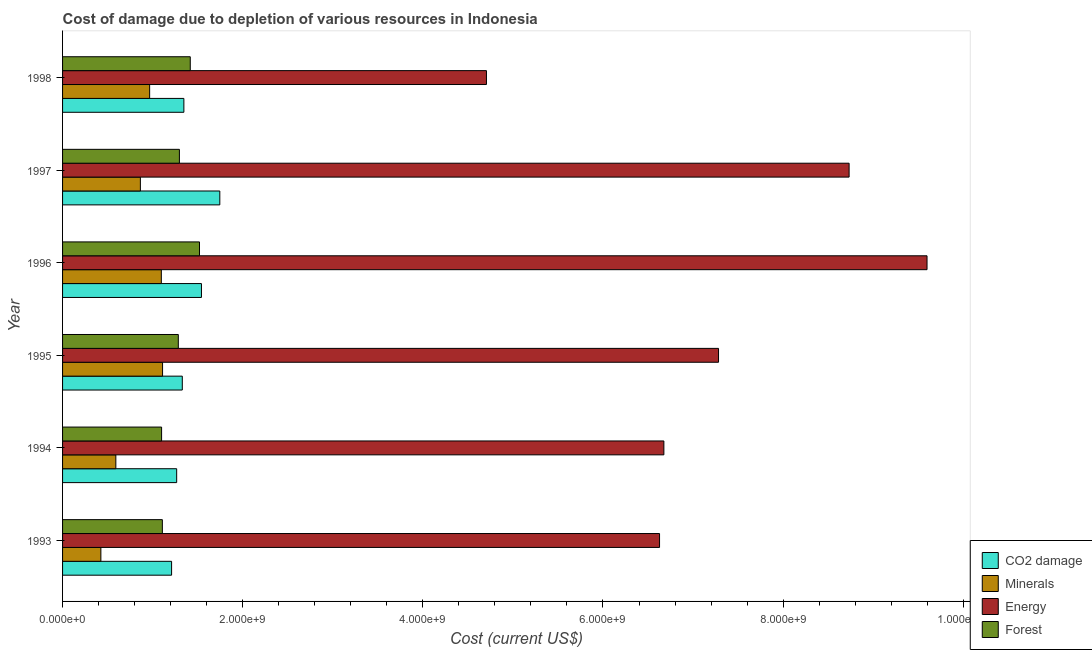Are the number of bars per tick equal to the number of legend labels?
Keep it short and to the point. Yes. How many bars are there on the 1st tick from the bottom?
Provide a short and direct response. 4. What is the cost of damage due to depletion of minerals in 1996?
Make the answer very short. 1.10e+09. Across all years, what is the maximum cost of damage due to depletion of energy?
Offer a very short reply. 9.60e+09. Across all years, what is the minimum cost of damage due to depletion of energy?
Keep it short and to the point. 4.71e+09. In which year was the cost of damage due to depletion of forests minimum?
Keep it short and to the point. 1994. What is the total cost of damage due to depletion of minerals in the graph?
Your answer should be very brief. 5.05e+09. What is the difference between the cost of damage due to depletion of energy in 1994 and that in 1997?
Provide a succinct answer. -2.06e+09. What is the difference between the cost of damage due to depletion of coal in 1997 and the cost of damage due to depletion of minerals in 1994?
Offer a very short reply. 1.15e+09. What is the average cost of damage due to depletion of minerals per year?
Ensure brevity in your answer.  8.42e+08. In the year 1994, what is the difference between the cost of damage due to depletion of coal and cost of damage due to depletion of minerals?
Make the answer very short. 6.75e+08. What is the ratio of the cost of damage due to depletion of energy in 1995 to that in 1996?
Offer a terse response. 0.76. Is the difference between the cost of damage due to depletion of minerals in 1995 and 1997 greater than the difference between the cost of damage due to depletion of forests in 1995 and 1997?
Give a very brief answer. Yes. What is the difference between the highest and the second highest cost of damage due to depletion of energy?
Offer a terse response. 8.65e+08. What is the difference between the highest and the lowest cost of damage due to depletion of forests?
Your answer should be compact. 4.21e+08. In how many years, is the cost of damage due to depletion of energy greater than the average cost of damage due to depletion of energy taken over all years?
Ensure brevity in your answer.  3. Is the sum of the cost of damage due to depletion of coal in 1994 and 1995 greater than the maximum cost of damage due to depletion of forests across all years?
Give a very brief answer. Yes. What does the 4th bar from the top in 1997 represents?
Give a very brief answer. CO2 damage. What does the 2nd bar from the bottom in 1995 represents?
Make the answer very short. Minerals. Are all the bars in the graph horizontal?
Offer a terse response. Yes. How many years are there in the graph?
Your answer should be compact. 6. Does the graph contain any zero values?
Offer a very short reply. No. Does the graph contain grids?
Provide a succinct answer. No. How many legend labels are there?
Give a very brief answer. 4. How are the legend labels stacked?
Your answer should be compact. Vertical. What is the title of the graph?
Provide a short and direct response. Cost of damage due to depletion of various resources in Indonesia . Does "Taxes on exports" appear as one of the legend labels in the graph?
Keep it short and to the point. No. What is the label or title of the X-axis?
Give a very brief answer. Cost (current US$). What is the label or title of the Y-axis?
Ensure brevity in your answer.  Year. What is the Cost (current US$) of CO2 damage in 1993?
Your answer should be compact. 1.21e+09. What is the Cost (current US$) in Minerals in 1993?
Ensure brevity in your answer.  4.25e+08. What is the Cost (current US$) in Energy in 1993?
Ensure brevity in your answer.  6.63e+09. What is the Cost (current US$) of Forest in 1993?
Make the answer very short. 1.11e+09. What is the Cost (current US$) in CO2 damage in 1994?
Keep it short and to the point. 1.27e+09. What is the Cost (current US$) in Minerals in 1994?
Keep it short and to the point. 5.92e+08. What is the Cost (current US$) of Energy in 1994?
Keep it short and to the point. 6.68e+09. What is the Cost (current US$) of Forest in 1994?
Give a very brief answer. 1.10e+09. What is the Cost (current US$) of CO2 damage in 1995?
Offer a terse response. 1.33e+09. What is the Cost (current US$) in Minerals in 1995?
Your response must be concise. 1.11e+09. What is the Cost (current US$) in Energy in 1995?
Provide a succinct answer. 7.28e+09. What is the Cost (current US$) in Forest in 1995?
Keep it short and to the point. 1.29e+09. What is the Cost (current US$) of CO2 damage in 1996?
Ensure brevity in your answer.  1.54e+09. What is the Cost (current US$) in Minerals in 1996?
Provide a short and direct response. 1.10e+09. What is the Cost (current US$) of Energy in 1996?
Make the answer very short. 9.60e+09. What is the Cost (current US$) in Forest in 1996?
Provide a succinct answer. 1.52e+09. What is the Cost (current US$) of CO2 damage in 1997?
Your response must be concise. 1.75e+09. What is the Cost (current US$) in Minerals in 1997?
Make the answer very short. 8.64e+08. What is the Cost (current US$) of Energy in 1997?
Ensure brevity in your answer.  8.73e+09. What is the Cost (current US$) in Forest in 1997?
Your response must be concise. 1.30e+09. What is the Cost (current US$) of CO2 damage in 1998?
Offer a very short reply. 1.35e+09. What is the Cost (current US$) of Minerals in 1998?
Provide a short and direct response. 9.67e+08. What is the Cost (current US$) of Energy in 1998?
Offer a terse response. 4.71e+09. What is the Cost (current US$) of Forest in 1998?
Offer a terse response. 1.42e+09. Across all years, what is the maximum Cost (current US$) of CO2 damage?
Provide a short and direct response. 1.75e+09. Across all years, what is the maximum Cost (current US$) of Minerals?
Your answer should be very brief. 1.11e+09. Across all years, what is the maximum Cost (current US$) in Energy?
Your response must be concise. 9.60e+09. Across all years, what is the maximum Cost (current US$) of Forest?
Your answer should be compact. 1.52e+09. Across all years, what is the minimum Cost (current US$) in CO2 damage?
Make the answer very short. 1.21e+09. Across all years, what is the minimum Cost (current US$) of Minerals?
Your answer should be very brief. 4.25e+08. Across all years, what is the minimum Cost (current US$) in Energy?
Provide a succinct answer. 4.71e+09. Across all years, what is the minimum Cost (current US$) of Forest?
Your response must be concise. 1.10e+09. What is the total Cost (current US$) of CO2 damage in the graph?
Make the answer very short. 8.44e+09. What is the total Cost (current US$) of Minerals in the graph?
Your answer should be very brief. 5.05e+09. What is the total Cost (current US$) in Energy in the graph?
Provide a short and direct response. 4.36e+1. What is the total Cost (current US$) of Forest in the graph?
Your response must be concise. 7.73e+09. What is the difference between the Cost (current US$) in CO2 damage in 1993 and that in 1994?
Your response must be concise. -5.64e+07. What is the difference between the Cost (current US$) in Minerals in 1993 and that in 1994?
Offer a terse response. -1.66e+08. What is the difference between the Cost (current US$) in Energy in 1993 and that in 1994?
Ensure brevity in your answer.  -4.81e+07. What is the difference between the Cost (current US$) in Forest in 1993 and that in 1994?
Your answer should be very brief. 8.36e+06. What is the difference between the Cost (current US$) of CO2 damage in 1993 and that in 1995?
Your answer should be compact. -1.19e+08. What is the difference between the Cost (current US$) in Minerals in 1993 and that in 1995?
Your answer should be compact. -6.85e+08. What is the difference between the Cost (current US$) in Energy in 1993 and that in 1995?
Give a very brief answer. -6.55e+08. What is the difference between the Cost (current US$) in Forest in 1993 and that in 1995?
Make the answer very short. -1.77e+08. What is the difference between the Cost (current US$) in CO2 damage in 1993 and that in 1996?
Provide a short and direct response. -3.32e+08. What is the difference between the Cost (current US$) in Minerals in 1993 and that in 1996?
Your answer should be compact. -6.71e+08. What is the difference between the Cost (current US$) of Energy in 1993 and that in 1996?
Provide a succinct answer. -2.97e+09. What is the difference between the Cost (current US$) of Forest in 1993 and that in 1996?
Make the answer very short. -4.12e+08. What is the difference between the Cost (current US$) in CO2 damage in 1993 and that in 1997?
Offer a terse response. -5.35e+08. What is the difference between the Cost (current US$) in Minerals in 1993 and that in 1997?
Provide a short and direct response. -4.39e+08. What is the difference between the Cost (current US$) of Energy in 1993 and that in 1997?
Your response must be concise. -2.10e+09. What is the difference between the Cost (current US$) in Forest in 1993 and that in 1997?
Ensure brevity in your answer.  -1.89e+08. What is the difference between the Cost (current US$) in CO2 damage in 1993 and that in 1998?
Offer a terse response. -1.36e+08. What is the difference between the Cost (current US$) in Minerals in 1993 and that in 1998?
Keep it short and to the point. -5.41e+08. What is the difference between the Cost (current US$) in Energy in 1993 and that in 1998?
Provide a short and direct response. 1.92e+09. What is the difference between the Cost (current US$) of Forest in 1993 and that in 1998?
Your answer should be very brief. -3.10e+08. What is the difference between the Cost (current US$) of CO2 damage in 1994 and that in 1995?
Ensure brevity in your answer.  -6.25e+07. What is the difference between the Cost (current US$) in Minerals in 1994 and that in 1995?
Ensure brevity in your answer.  -5.19e+08. What is the difference between the Cost (current US$) in Energy in 1994 and that in 1995?
Provide a short and direct response. -6.07e+08. What is the difference between the Cost (current US$) of Forest in 1994 and that in 1995?
Your answer should be very brief. -1.86e+08. What is the difference between the Cost (current US$) in CO2 damage in 1994 and that in 1996?
Make the answer very short. -2.75e+08. What is the difference between the Cost (current US$) in Minerals in 1994 and that in 1996?
Provide a short and direct response. -5.05e+08. What is the difference between the Cost (current US$) in Energy in 1994 and that in 1996?
Ensure brevity in your answer.  -2.92e+09. What is the difference between the Cost (current US$) of Forest in 1994 and that in 1996?
Your answer should be very brief. -4.21e+08. What is the difference between the Cost (current US$) in CO2 damage in 1994 and that in 1997?
Offer a very short reply. -4.79e+08. What is the difference between the Cost (current US$) of Minerals in 1994 and that in 1997?
Your response must be concise. -2.72e+08. What is the difference between the Cost (current US$) of Energy in 1994 and that in 1997?
Offer a terse response. -2.06e+09. What is the difference between the Cost (current US$) of Forest in 1994 and that in 1997?
Offer a very short reply. -1.98e+08. What is the difference between the Cost (current US$) in CO2 damage in 1994 and that in 1998?
Give a very brief answer. -8.01e+07. What is the difference between the Cost (current US$) of Minerals in 1994 and that in 1998?
Provide a succinct answer. -3.75e+08. What is the difference between the Cost (current US$) in Energy in 1994 and that in 1998?
Provide a succinct answer. 1.97e+09. What is the difference between the Cost (current US$) in Forest in 1994 and that in 1998?
Your response must be concise. -3.18e+08. What is the difference between the Cost (current US$) in CO2 damage in 1995 and that in 1996?
Your answer should be compact. -2.13e+08. What is the difference between the Cost (current US$) in Minerals in 1995 and that in 1996?
Offer a very short reply. 1.37e+07. What is the difference between the Cost (current US$) in Energy in 1995 and that in 1996?
Give a very brief answer. -2.31e+09. What is the difference between the Cost (current US$) in Forest in 1995 and that in 1996?
Provide a short and direct response. -2.35e+08. What is the difference between the Cost (current US$) of CO2 damage in 1995 and that in 1997?
Offer a terse response. -4.17e+08. What is the difference between the Cost (current US$) in Minerals in 1995 and that in 1997?
Provide a short and direct response. 2.46e+08. What is the difference between the Cost (current US$) in Energy in 1995 and that in 1997?
Ensure brevity in your answer.  -1.45e+09. What is the difference between the Cost (current US$) in Forest in 1995 and that in 1997?
Your response must be concise. -1.22e+07. What is the difference between the Cost (current US$) of CO2 damage in 1995 and that in 1998?
Your answer should be compact. -1.76e+07. What is the difference between the Cost (current US$) of Minerals in 1995 and that in 1998?
Keep it short and to the point. 1.44e+08. What is the difference between the Cost (current US$) in Energy in 1995 and that in 1998?
Ensure brevity in your answer.  2.58e+09. What is the difference between the Cost (current US$) in Forest in 1995 and that in 1998?
Provide a short and direct response. -1.33e+08. What is the difference between the Cost (current US$) of CO2 damage in 1996 and that in 1997?
Offer a very short reply. -2.04e+08. What is the difference between the Cost (current US$) in Minerals in 1996 and that in 1997?
Provide a short and direct response. 2.33e+08. What is the difference between the Cost (current US$) of Energy in 1996 and that in 1997?
Your response must be concise. 8.65e+08. What is the difference between the Cost (current US$) of Forest in 1996 and that in 1997?
Your answer should be very brief. 2.23e+08. What is the difference between the Cost (current US$) in CO2 damage in 1996 and that in 1998?
Provide a short and direct response. 1.95e+08. What is the difference between the Cost (current US$) of Minerals in 1996 and that in 1998?
Offer a very short reply. 1.30e+08. What is the difference between the Cost (current US$) of Energy in 1996 and that in 1998?
Provide a short and direct response. 4.89e+09. What is the difference between the Cost (current US$) in Forest in 1996 and that in 1998?
Provide a succinct answer. 1.02e+08. What is the difference between the Cost (current US$) of CO2 damage in 1997 and that in 1998?
Provide a short and direct response. 3.99e+08. What is the difference between the Cost (current US$) in Minerals in 1997 and that in 1998?
Provide a succinct answer. -1.03e+08. What is the difference between the Cost (current US$) of Energy in 1997 and that in 1998?
Your answer should be very brief. 4.03e+09. What is the difference between the Cost (current US$) in Forest in 1997 and that in 1998?
Make the answer very short. -1.21e+08. What is the difference between the Cost (current US$) of CO2 damage in 1993 and the Cost (current US$) of Minerals in 1994?
Your answer should be compact. 6.19e+08. What is the difference between the Cost (current US$) of CO2 damage in 1993 and the Cost (current US$) of Energy in 1994?
Provide a succinct answer. -5.47e+09. What is the difference between the Cost (current US$) of CO2 damage in 1993 and the Cost (current US$) of Forest in 1994?
Keep it short and to the point. 1.11e+08. What is the difference between the Cost (current US$) in Minerals in 1993 and the Cost (current US$) in Energy in 1994?
Provide a short and direct response. -6.25e+09. What is the difference between the Cost (current US$) in Minerals in 1993 and the Cost (current US$) in Forest in 1994?
Provide a succinct answer. -6.74e+08. What is the difference between the Cost (current US$) of Energy in 1993 and the Cost (current US$) of Forest in 1994?
Your response must be concise. 5.53e+09. What is the difference between the Cost (current US$) of CO2 damage in 1993 and the Cost (current US$) of Minerals in 1995?
Give a very brief answer. 1.00e+08. What is the difference between the Cost (current US$) of CO2 damage in 1993 and the Cost (current US$) of Energy in 1995?
Give a very brief answer. -6.07e+09. What is the difference between the Cost (current US$) of CO2 damage in 1993 and the Cost (current US$) of Forest in 1995?
Keep it short and to the point. -7.47e+07. What is the difference between the Cost (current US$) in Minerals in 1993 and the Cost (current US$) in Energy in 1995?
Offer a very short reply. -6.86e+09. What is the difference between the Cost (current US$) of Minerals in 1993 and the Cost (current US$) of Forest in 1995?
Make the answer very short. -8.60e+08. What is the difference between the Cost (current US$) in Energy in 1993 and the Cost (current US$) in Forest in 1995?
Provide a succinct answer. 5.34e+09. What is the difference between the Cost (current US$) of CO2 damage in 1993 and the Cost (current US$) of Minerals in 1996?
Make the answer very short. 1.14e+08. What is the difference between the Cost (current US$) in CO2 damage in 1993 and the Cost (current US$) in Energy in 1996?
Provide a succinct answer. -8.39e+09. What is the difference between the Cost (current US$) of CO2 damage in 1993 and the Cost (current US$) of Forest in 1996?
Provide a succinct answer. -3.10e+08. What is the difference between the Cost (current US$) in Minerals in 1993 and the Cost (current US$) in Energy in 1996?
Offer a terse response. -9.17e+09. What is the difference between the Cost (current US$) in Minerals in 1993 and the Cost (current US$) in Forest in 1996?
Ensure brevity in your answer.  -1.10e+09. What is the difference between the Cost (current US$) of Energy in 1993 and the Cost (current US$) of Forest in 1996?
Offer a terse response. 5.11e+09. What is the difference between the Cost (current US$) of CO2 damage in 1993 and the Cost (current US$) of Minerals in 1997?
Your response must be concise. 3.47e+08. What is the difference between the Cost (current US$) of CO2 damage in 1993 and the Cost (current US$) of Energy in 1997?
Keep it short and to the point. -7.52e+09. What is the difference between the Cost (current US$) in CO2 damage in 1993 and the Cost (current US$) in Forest in 1997?
Your response must be concise. -8.68e+07. What is the difference between the Cost (current US$) in Minerals in 1993 and the Cost (current US$) in Energy in 1997?
Your answer should be compact. -8.31e+09. What is the difference between the Cost (current US$) of Minerals in 1993 and the Cost (current US$) of Forest in 1997?
Offer a very short reply. -8.72e+08. What is the difference between the Cost (current US$) in Energy in 1993 and the Cost (current US$) in Forest in 1997?
Offer a terse response. 5.33e+09. What is the difference between the Cost (current US$) of CO2 damage in 1993 and the Cost (current US$) of Minerals in 1998?
Your answer should be compact. 2.44e+08. What is the difference between the Cost (current US$) in CO2 damage in 1993 and the Cost (current US$) in Energy in 1998?
Offer a terse response. -3.50e+09. What is the difference between the Cost (current US$) in CO2 damage in 1993 and the Cost (current US$) in Forest in 1998?
Offer a very short reply. -2.07e+08. What is the difference between the Cost (current US$) of Minerals in 1993 and the Cost (current US$) of Energy in 1998?
Keep it short and to the point. -4.28e+09. What is the difference between the Cost (current US$) in Minerals in 1993 and the Cost (current US$) in Forest in 1998?
Keep it short and to the point. -9.93e+08. What is the difference between the Cost (current US$) in Energy in 1993 and the Cost (current US$) in Forest in 1998?
Provide a short and direct response. 5.21e+09. What is the difference between the Cost (current US$) of CO2 damage in 1994 and the Cost (current US$) of Minerals in 1995?
Give a very brief answer. 1.57e+08. What is the difference between the Cost (current US$) of CO2 damage in 1994 and the Cost (current US$) of Energy in 1995?
Your response must be concise. -6.02e+09. What is the difference between the Cost (current US$) of CO2 damage in 1994 and the Cost (current US$) of Forest in 1995?
Your answer should be compact. -1.83e+07. What is the difference between the Cost (current US$) in Minerals in 1994 and the Cost (current US$) in Energy in 1995?
Make the answer very short. -6.69e+09. What is the difference between the Cost (current US$) in Minerals in 1994 and the Cost (current US$) in Forest in 1995?
Keep it short and to the point. -6.94e+08. What is the difference between the Cost (current US$) of Energy in 1994 and the Cost (current US$) of Forest in 1995?
Your answer should be very brief. 5.39e+09. What is the difference between the Cost (current US$) in CO2 damage in 1994 and the Cost (current US$) in Minerals in 1996?
Give a very brief answer. 1.70e+08. What is the difference between the Cost (current US$) in CO2 damage in 1994 and the Cost (current US$) in Energy in 1996?
Ensure brevity in your answer.  -8.33e+09. What is the difference between the Cost (current US$) in CO2 damage in 1994 and the Cost (current US$) in Forest in 1996?
Offer a terse response. -2.54e+08. What is the difference between the Cost (current US$) of Minerals in 1994 and the Cost (current US$) of Energy in 1996?
Your response must be concise. -9.01e+09. What is the difference between the Cost (current US$) of Minerals in 1994 and the Cost (current US$) of Forest in 1996?
Your answer should be very brief. -9.29e+08. What is the difference between the Cost (current US$) of Energy in 1994 and the Cost (current US$) of Forest in 1996?
Offer a terse response. 5.16e+09. What is the difference between the Cost (current US$) in CO2 damage in 1994 and the Cost (current US$) in Minerals in 1997?
Your response must be concise. 4.03e+08. What is the difference between the Cost (current US$) of CO2 damage in 1994 and the Cost (current US$) of Energy in 1997?
Ensure brevity in your answer.  -7.47e+09. What is the difference between the Cost (current US$) of CO2 damage in 1994 and the Cost (current US$) of Forest in 1997?
Offer a terse response. -3.05e+07. What is the difference between the Cost (current US$) of Minerals in 1994 and the Cost (current US$) of Energy in 1997?
Give a very brief answer. -8.14e+09. What is the difference between the Cost (current US$) in Minerals in 1994 and the Cost (current US$) in Forest in 1997?
Give a very brief answer. -7.06e+08. What is the difference between the Cost (current US$) of Energy in 1994 and the Cost (current US$) of Forest in 1997?
Offer a terse response. 5.38e+09. What is the difference between the Cost (current US$) of CO2 damage in 1994 and the Cost (current US$) of Minerals in 1998?
Ensure brevity in your answer.  3.00e+08. What is the difference between the Cost (current US$) in CO2 damage in 1994 and the Cost (current US$) in Energy in 1998?
Ensure brevity in your answer.  -3.44e+09. What is the difference between the Cost (current US$) in CO2 damage in 1994 and the Cost (current US$) in Forest in 1998?
Provide a succinct answer. -1.51e+08. What is the difference between the Cost (current US$) in Minerals in 1994 and the Cost (current US$) in Energy in 1998?
Keep it short and to the point. -4.11e+09. What is the difference between the Cost (current US$) of Minerals in 1994 and the Cost (current US$) of Forest in 1998?
Your response must be concise. -8.26e+08. What is the difference between the Cost (current US$) in Energy in 1994 and the Cost (current US$) in Forest in 1998?
Offer a very short reply. 5.26e+09. What is the difference between the Cost (current US$) of CO2 damage in 1995 and the Cost (current US$) of Minerals in 1996?
Provide a short and direct response. 2.33e+08. What is the difference between the Cost (current US$) of CO2 damage in 1995 and the Cost (current US$) of Energy in 1996?
Offer a terse response. -8.27e+09. What is the difference between the Cost (current US$) of CO2 damage in 1995 and the Cost (current US$) of Forest in 1996?
Make the answer very short. -1.91e+08. What is the difference between the Cost (current US$) of Minerals in 1995 and the Cost (current US$) of Energy in 1996?
Keep it short and to the point. -8.49e+09. What is the difference between the Cost (current US$) of Minerals in 1995 and the Cost (current US$) of Forest in 1996?
Provide a succinct answer. -4.10e+08. What is the difference between the Cost (current US$) in Energy in 1995 and the Cost (current US$) in Forest in 1996?
Provide a short and direct response. 5.76e+09. What is the difference between the Cost (current US$) of CO2 damage in 1995 and the Cost (current US$) of Minerals in 1997?
Make the answer very short. 4.65e+08. What is the difference between the Cost (current US$) in CO2 damage in 1995 and the Cost (current US$) in Energy in 1997?
Give a very brief answer. -7.40e+09. What is the difference between the Cost (current US$) of CO2 damage in 1995 and the Cost (current US$) of Forest in 1997?
Give a very brief answer. 3.20e+07. What is the difference between the Cost (current US$) of Minerals in 1995 and the Cost (current US$) of Energy in 1997?
Give a very brief answer. -7.62e+09. What is the difference between the Cost (current US$) in Minerals in 1995 and the Cost (current US$) in Forest in 1997?
Give a very brief answer. -1.87e+08. What is the difference between the Cost (current US$) in Energy in 1995 and the Cost (current US$) in Forest in 1997?
Keep it short and to the point. 5.99e+09. What is the difference between the Cost (current US$) of CO2 damage in 1995 and the Cost (current US$) of Minerals in 1998?
Your answer should be compact. 3.63e+08. What is the difference between the Cost (current US$) in CO2 damage in 1995 and the Cost (current US$) in Energy in 1998?
Keep it short and to the point. -3.38e+09. What is the difference between the Cost (current US$) in CO2 damage in 1995 and the Cost (current US$) in Forest in 1998?
Your answer should be compact. -8.86e+07. What is the difference between the Cost (current US$) in Minerals in 1995 and the Cost (current US$) in Energy in 1998?
Offer a very short reply. -3.60e+09. What is the difference between the Cost (current US$) of Minerals in 1995 and the Cost (current US$) of Forest in 1998?
Ensure brevity in your answer.  -3.08e+08. What is the difference between the Cost (current US$) in Energy in 1995 and the Cost (current US$) in Forest in 1998?
Make the answer very short. 5.87e+09. What is the difference between the Cost (current US$) in CO2 damage in 1996 and the Cost (current US$) in Minerals in 1997?
Give a very brief answer. 6.78e+08. What is the difference between the Cost (current US$) in CO2 damage in 1996 and the Cost (current US$) in Energy in 1997?
Offer a very short reply. -7.19e+09. What is the difference between the Cost (current US$) in CO2 damage in 1996 and the Cost (current US$) in Forest in 1997?
Provide a succinct answer. 2.45e+08. What is the difference between the Cost (current US$) in Minerals in 1996 and the Cost (current US$) in Energy in 1997?
Provide a short and direct response. -7.64e+09. What is the difference between the Cost (current US$) of Minerals in 1996 and the Cost (current US$) of Forest in 1997?
Provide a short and direct response. -2.01e+08. What is the difference between the Cost (current US$) in Energy in 1996 and the Cost (current US$) in Forest in 1997?
Keep it short and to the point. 8.30e+09. What is the difference between the Cost (current US$) of CO2 damage in 1996 and the Cost (current US$) of Minerals in 1998?
Provide a succinct answer. 5.75e+08. What is the difference between the Cost (current US$) of CO2 damage in 1996 and the Cost (current US$) of Energy in 1998?
Give a very brief answer. -3.16e+09. What is the difference between the Cost (current US$) in CO2 damage in 1996 and the Cost (current US$) in Forest in 1998?
Your response must be concise. 1.24e+08. What is the difference between the Cost (current US$) in Minerals in 1996 and the Cost (current US$) in Energy in 1998?
Make the answer very short. -3.61e+09. What is the difference between the Cost (current US$) of Minerals in 1996 and the Cost (current US$) of Forest in 1998?
Your response must be concise. -3.21e+08. What is the difference between the Cost (current US$) in Energy in 1996 and the Cost (current US$) in Forest in 1998?
Give a very brief answer. 8.18e+09. What is the difference between the Cost (current US$) of CO2 damage in 1997 and the Cost (current US$) of Minerals in 1998?
Give a very brief answer. 7.79e+08. What is the difference between the Cost (current US$) in CO2 damage in 1997 and the Cost (current US$) in Energy in 1998?
Your response must be concise. -2.96e+09. What is the difference between the Cost (current US$) in CO2 damage in 1997 and the Cost (current US$) in Forest in 1998?
Offer a terse response. 3.28e+08. What is the difference between the Cost (current US$) in Minerals in 1997 and the Cost (current US$) in Energy in 1998?
Provide a succinct answer. -3.84e+09. What is the difference between the Cost (current US$) in Minerals in 1997 and the Cost (current US$) in Forest in 1998?
Provide a succinct answer. -5.54e+08. What is the difference between the Cost (current US$) in Energy in 1997 and the Cost (current US$) in Forest in 1998?
Your answer should be very brief. 7.31e+09. What is the average Cost (current US$) in CO2 damage per year?
Your response must be concise. 1.41e+09. What is the average Cost (current US$) of Minerals per year?
Offer a very short reply. 8.42e+08. What is the average Cost (current US$) in Energy per year?
Give a very brief answer. 7.27e+09. What is the average Cost (current US$) of Forest per year?
Offer a very short reply. 1.29e+09. In the year 1993, what is the difference between the Cost (current US$) of CO2 damage and Cost (current US$) of Minerals?
Make the answer very short. 7.85e+08. In the year 1993, what is the difference between the Cost (current US$) of CO2 damage and Cost (current US$) of Energy?
Keep it short and to the point. -5.42e+09. In the year 1993, what is the difference between the Cost (current US$) of CO2 damage and Cost (current US$) of Forest?
Provide a short and direct response. 1.03e+08. In the year 1993, what is the difference between the Cost (current US$) of Minerals and Cost (current US$) of Energy?
Your answer should be compact. -6.20e+09. In the year 1993, what is the difference between the Cost (current US$) in Minerals and Cost (current US$) in Forest?
Make the answer very short. -6.83e+08. In the year 1993, what is the difference between the Cost (current US$) of Energy and Cost (current US$) of Forest?
Make the answer very short. 5.52e+09. In the year 1994, what is the difference between the Cost (current US$) of CO2 damage and Cost (current US$) of Minerals?
Make the answer very short. 6.75e+08. In the year 1994, what is the difference between the Cost (current US$) in CO2 damage and Cost (current US$) in Energy?
Keep it short and to the point. -5.41e+09. In the year 1994, what is the difference between the Cost (current US$) of CO2 damage and Cost (current US$) of Forest?
Offer a terse response. 1.67e+08. In the year 1994, what is the difference between the Cost (current US$) of Minerals and Cost (current US$) of Energy?
Keep it short and to the point. -6.08e+09. In the year 1994, what is the difference between the Cost (current US$) in Minerals and Cost (current US$) in Forest?
Keep it short and to the point. -5.08e+08. In the year 1994, what is the difference between the Cost (current US$) in Energy and Cost (current US$) in Forest?
Provide a succinct answer. 5.58e+09. In the year 1995, what is the difference between the Cost (current US$) of CO2 damage and Cost (current US$) of Minerals?
Your answer should be very brief. 2.19e+08. In the year 1995, what is the difference between the Cost (current US$) of CO2 damage and Cost (current US$) of Energy?
Your answer should be compact. -5.95e+09. In the year 1995, what is the difference between the Cost (current US$) in CO2 damage and Cost (current US$) in Forest?
Your answer should be very brief. 4.42e+07. In the year 1995, what is the difference between the Cost (current US$) in Minerals and Cost (current US$) in Energy?
Keep it short and to the point. -6.17e+09. In the year 1995, what is the difference between the Cost (current US$) in Minerals and Cost (current US$) in Forest?
Your answer should be compact. -1.75e+08. In the year 1995, what is the difference between the Cost (current US$) of Energy and Cost (current US$) of Forest?
Offer a very short reply. 6.00e+09. In the year 1996, what is the difference between the Cost (current US$) in CO2 damage and Cost (current US$) in Minerals?
Make the answer very short. 4.45e+08. In the year 1996, what is the difference between the Cost (current US$) of CO2 damage and Cost (current US$) of Energy?
Ensure brevity in your answer.  -8.06e+09. In the year 1996, what is the difference between the Cost (current US$) of CO2 damage and Cost (current US$) of Forest?
Your response must be concise. 2.17e+07. In the year 1996, what is the difference between the Cost (current US$) of Minerals and Cost (current US$) of Energy?
Keep it short and to the point. -8.50e+09. In the year 1996, what is the difference between the Cost (current US$) of Minerals and Cost (current US$) of Forest?
Provide a succinct answer. -4.24e+08. In the year 1996, what is the difference between the Cost (current US$) in Energy and Cost (current US$) in Forest?
Provide a short and direct response. 8.08e+09. In the year 1997, what is the difference between the Cost (current US$) of CO2 damage and Cost (current US$) of Minerals?
Make the answer very short. 8.82e+08. In the year 1997, what is the difference between the Cost (current US$) of CO2 damage and Cost (current US$) of Energy?
Make the answer very short. -6.99e+09. In the year 1997, what is the difference between the Cost (current US$) in CO2 damage and Cost (current US$) in Forest?
Offer a very short reply. 4.49e+08. In the year 1997, what is the difference between the Cost (current US$) in Minerals and Cost (current US$) in Energy?
Make the answer very short. -7.87e+09. In the year 1997, what is the difference between the Cost (current US$) in Minerals and Cost (current US$) in Forest?
Make the answer very short. -4.33e+08. In the year 1997, what is the difference between the Cost (current US$) in Energy and Cost (current US$) in Forest?
Offer a very short reply. 7.44e+09. In the year 1998, what is the difference between the Cost (current US$) in CO2 damage and Cost (current US$) in Minerals?
Your response must be concise. 3.80e+08. In the year 1998, what is the difference between the Cost (current US$) of CO2 damage and Cost (current US$) of Energy?
Keep it short and to the point. -3.36e+09. In the year 1998, what is the difference between the Cost (current US$) of CO2 damage and Cost (current US$) of Forest?
Give a very brief answer. -7.10e+07. In the year 1998, what is the difference between the Cost (current US$) in Minerals and Cost (current US$) in Energy?
Offer a very short reply. -3.74e+09. In the year 1998, what is the difference between the Cost (current US$) in Minerals and Cost (current US$) in Forest?
Your response must be concise. -4.51e+08. In the year 1998, what is the difference between the Cost (current US$) of Energy and Cost (current US$) of Forest?
Make the answer very short. 3.29e+09. What is the ratio of the Cost (current US$) in CO2 damage in 1993 to that in 1994?
Keep it short and to the point. 0.96. What is the ratio of the Cost (current US$) in Minerals in 1993 to that in 1994?
Your answer should be compact. 0.72. What is the ratio of the Cost (current US$) in Energy in 1993 to that in 1994?
Give a very brief answer. 0.99. What is the ratio of the Cost (current US$) of Forest in 1993 to that in 1994?
Give a very brief answer. 1.01. What is the ratio of the Cost (current US$) of CO2 damage in 1993 to that in 1995?
Provide a succinct answer. 0.91. What is the ratio of the Cost (current US$) of Minerals in 1993 to that in 1995?
Offer a very short reply. 0.38. What is the ratio of the Cost (current US$) in Energy in 1993 to that in 1995?
Ensure brevity in your answer.  0.91. What is the ratio of the Cost (current US$) of Forest in 1993 to that in 1995?
Provide a succinct answer. 0.86. What is the ratio of the Cost (current US$) of CO2 damage in 1993 to that in 1996?
Offer a very short reply. 0.79. What is the ratio of the Cost (current US$) in Minerals in 1993 to that in 1996?
Offer a terse response. 0.39. What is the ratio of the Cost (current US$) in Energy in 1993 to that in 1996?
Offer a very short reply. 0.69. What is the ratio of the Cost (current US$) of Forest in 1993 to that in 1996?
Provide a short and direct response. 0.73. What is the ratio of the Cost (current US$) of CO2 damage in 1993 to that in 1997?
Your answer should be very brief. 0.69. What is the ratio of the Cost (current US$) of Minerals in 1993 to that in 1997?
Your answer should be compact. 0.49. What is the ratio of the Cost (current US$) of Energy in 1993 to that in 1997?
Offer a terse response. 0.76. What is the ratio of the Cost (current US$) of Forest in 1993 to that in 1997?
Your answer should be very brief. 0.85. What is the ratio of the Cost (current US$) of CO2 damage in 1993 to that in 1998?
Your answer should be very brief. 0.9. What is the ratio of the Cost (current US$) in Minerals in 1993 to that in 1998?
Provide a succinct answer. 0.44. What is the ratio of the Cost (current US$) in Energy in 1993 to that in 1998?
Ensure brevity in your answer.  1.41. What is the ratio of the Cost (current US$) of Forest in 1993 to that in 1998?
Offer a very short reply. 0.78. What is the ratio of the Cost (current US$) in CO2 damage in 1994 to that in 1995?
Make the answer very short. 0.95. What is the ratio of the Cost (current US$) of Minerals in 1994 to that in 1995?
Your answer should be very brief. 0.53. What is the ratio of the Cost (current US$) of Forest in 1994 to that in 1995?
Your answer should be compact. 0.86. What is the ratio of the Cost (current US$) of CO2 damage in 1994 to that in 1996?
Give a very brief answer. 0.82. What is the ratio of the Cost (current US$) of Minerals in 1994 to that in 1996?
Offer a terse response. 0.54. What is the ratio of the Cost (current US$) of Energy in 1994 to that in 1996?
Offer a very short reply. 0.7. What is the ratio of the Cost (current US$) of Forest in 1994 to that in 1996?
Your response must be concise. 0.72. What is the ratio of the Cost (current US$) in CO2 damage in 1994 to that in 1997?
Your answer should be compact. 0.73. What is the ratio of the Cost (current US$) in Minerals in 1994 to that in 1997?
Your answer should be compact. 0.68. What is the ratio of the Cost (current US$) in Energy in 1994 to that in 1997?
Provide a succinct answer. 0.76. What is the ratio of the Cost (current US$) of Forest in 1994 to that in 1997?
Offer a terse response. 0.85. What is the ratio of the Cost (current US$) of CO2 damage in 1994 to that in 1998?
Your answer should be very brief. 0.94. What is the ratio of the Cost (current US$) of Minerals in 1994 to that in 1998?
Provide a short and direct response. 0.61. What is the ratio of the Cost (current US$) of Energy in 1994 to that in 1998?
Make the answer very short. 1.42. What is the ratio of the Cost (current US$) in Forest in 1994 to that in 1998?
Your response must be concise. 0.78. What is the ratio of the Cost (current US$) in CO2 damage in 1995 to that in 1996?
Your answer should be compact. 0.86. What is the ratio of the Cost (current US$) of Minerals in 1995 to that in 1996?
Ensure brevity in your answer.  1.01. What is the ratio of the Cost (current US$) in Energy in 1995 to that in 1996?
Make the answer very short. 0.76. What is the ratio of the Cost (current US$) of Forest in 1995 to that in 1996?
Your answer should be very brief. 0.85. What is the ratio of the Cost (current US$) in CO2 damage in 1995 to that in 1997?
Ensure brevity in your answer.  0.76. What is the ratio of the Cost (current US$) in Minerals in 1995 to that in 1997?
Your answer should be very brief. 1.29. What is the ratio of the Cost (current US$) in Energy in 1995 to that in 1997?
Offer a very short reply. 0.83. What is the ratio of the Cost (current US$) in Forest in 1995 to that in 1997?
Offer a terse response. 0.99. What is the ratio of the Cost (current US$) of CO2 damage in 1995 to that in 1998?
Ensure brevity in your answer.  0.99. What is the ratio of the Cost (current US$) of Minerals in 1995 to that in 1998?
Your answer should be compact. 1.15. What is the ratio of the Cost (current US$) of Energy in 1995 to that in 1998?
Offer a terse response. 1.55. What is the ratio of the Cost (current US$) in Forest in 1995 to that in 1998?
Make the answer very short. 0.91. What is the ratio of the Cost (current US$) in CO2 damage in 1996 to that in 1997?
Make the answer very short. 0.88. What is the ratio of the Cost (current US$) of Minerals in 1996 to that in 1997?
Provide a succinct answer. 1.27. What is the ratio of the Cost (current US$) of Energy in 1996 to that in 1997?
Provide a succinct answer. 1.1. What is the ratio of the Cost (current US$) of Forest in 1996 to that in 1997?
Ensure brevity in your answer.  1.17. What is the ratio of the Cost (current US$) in CO2 damage in 1996 to that in 1998?
Keep it short and to the point. 1.14. What is the ratio of the Cost (current US$) of Minerals in 1996 to that in 1998?
Provide a short and direct response. 1.13. What is the ratio of the Cost (current US$) in Energy in 1996 to that in 1998?
Provide a succinct answer. 2.04. What is the ratio of the Cost (current US$) in Forest in 1996 to that in 1998?
Offer a terse response. 1.07. What is the ratio of the Cost (current US$) in CO2 damage in 1997 to that in 1998?
Give a very brief answer. 1.3. What is the ratio of the Cost (current US$) of Minerals in 1997 to that in 1998?
Give a very brief answer. 0.89. What is the ratio of the Cost (current US$) of Energy in 1997 to that in 1998?
Offer a very short reply. 1.86. What is the ratio of the Cost (current US$) of Forest in 1997 to that in 1998?
Give a very brief answer. 0.92. What is the difference between the highest and the second highest Cost (current US$) of CO2 damage?
Ensure brevity in your answer.  2.04e+08. What is the difference between the highest and the second highest Cost (current US$) in Minerals?
Provide a short and direct response. 1.37e+07. What is the difference between the highest and the second highest Cost (current US$) of Energy?
Ensure brevity in your answer.  8.65e+08. What is the difference between the highest and the second highest Cost (current US$) in Forest?
Ensure brevity in your answer.  1.02e+08. What is the difference between the highest and the lowest Cost (current US$) of CO2 damage?
Give a very brief answer. 5.35e+08. What is the difference between the highest and the lowest Cost (current US$) of Minerals?
Your answer should be very brief. 6.85e+08. What is the difference between the highest and the lowest Cost (current US$) in Energy?
Keep it short and to the point. 4.89e+09. What is the difference between the highest and the lowest Cost (current US$) of Forest?
Offer a very short reply. 4.21e+08. 